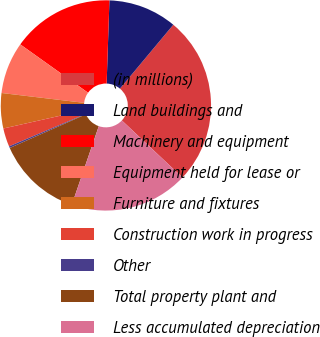<chart> <loc_0><loc_0><loc_500><loc_500><pie_chart><fcel>(in millions)<fcel>Land buildings and<fcel>Machinery and equipment<fcel>Equipment held for lease or<fcel>Furniture and fixtures<fcel>Construction work in progress<fcel>Other<fcel>Total property plant and<fcel>Less accumulated depreciation<nl><fcel>25.95%<fcel>10.54%<fcel>15.68%<fcel>7.97%<fcel>5.41%<fcel>2.84%<fcel>0.27%<fcel>13.11%<fcel>18.24%<nl></chart> 